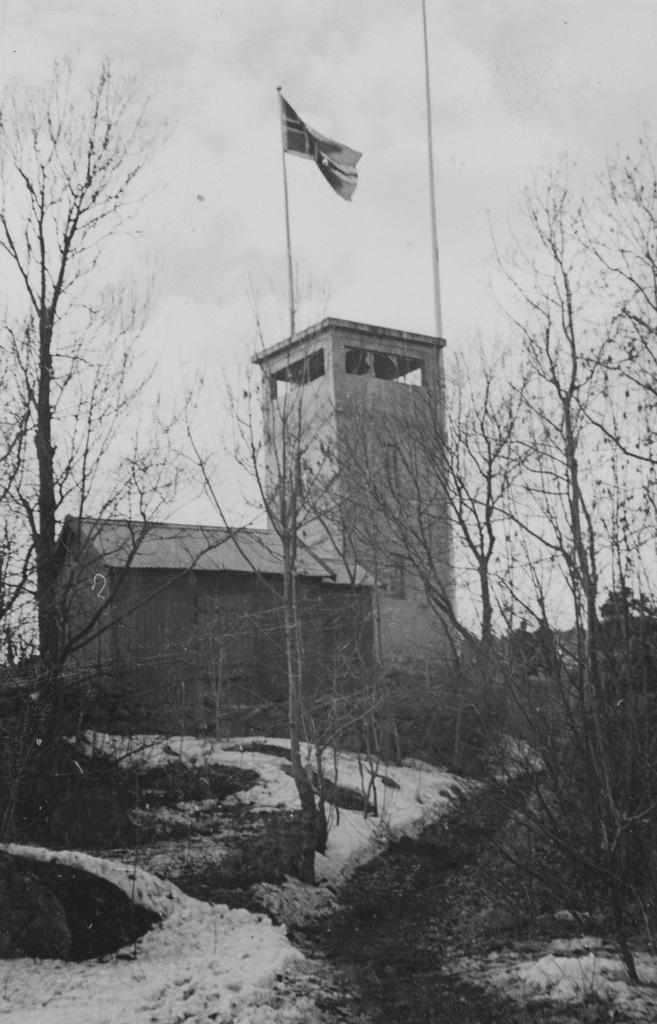In one or two sentences, can you explain what this image depicts? In this image there are rocks, trees. At the bottom of the image there is snow on the surface. In the center of the image there is a building. There is a flag. In the background of the image there is sky. 